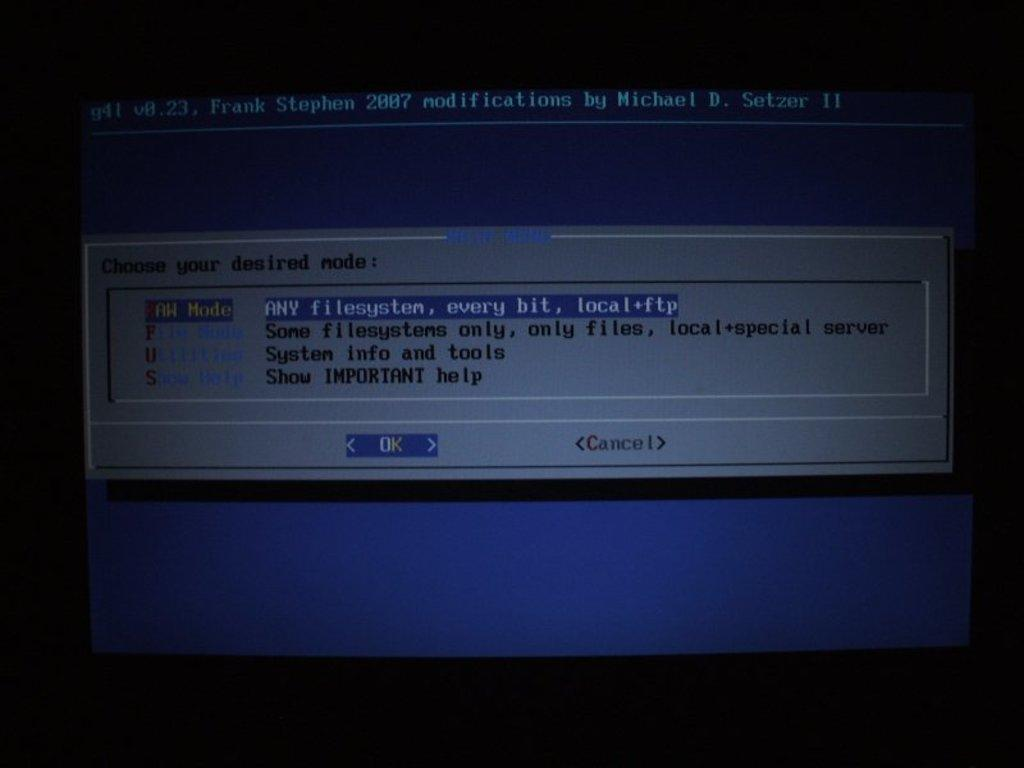Provide a one-sentence caption for the provided image. A notification on the computer screen has the OK button highlighted. 